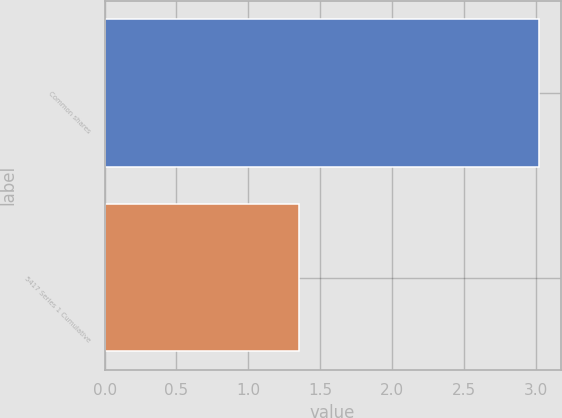Convert chart. <chart><loc_0><loc_0><loc_500><loc_500><bar_chart><fcel>Common shares<fcel>5417 Series 1 Cumulative<nl><fcel>3.02<fcel>1.35<nl></chart> 